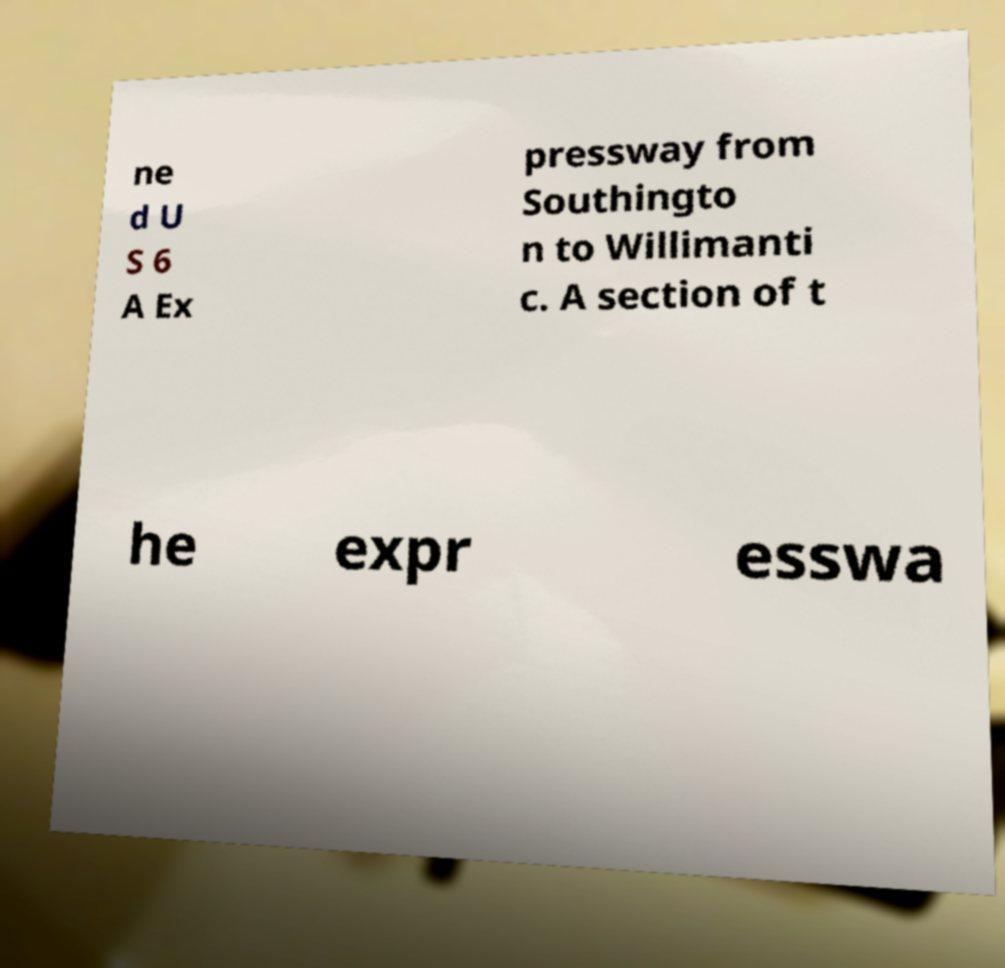For documentation purposes, I need the text within this image transcribed. Could you provide that? ne d U S 6 A Ex pressway from Southingto n to Willimanti c. A section of t he expr esswa 